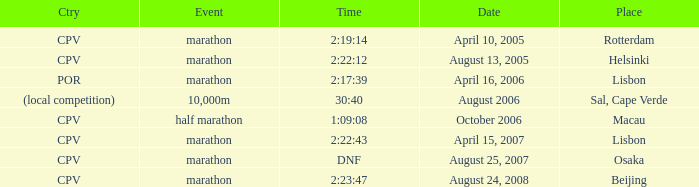What is the Country of the 10,000m Event? (local competition). 